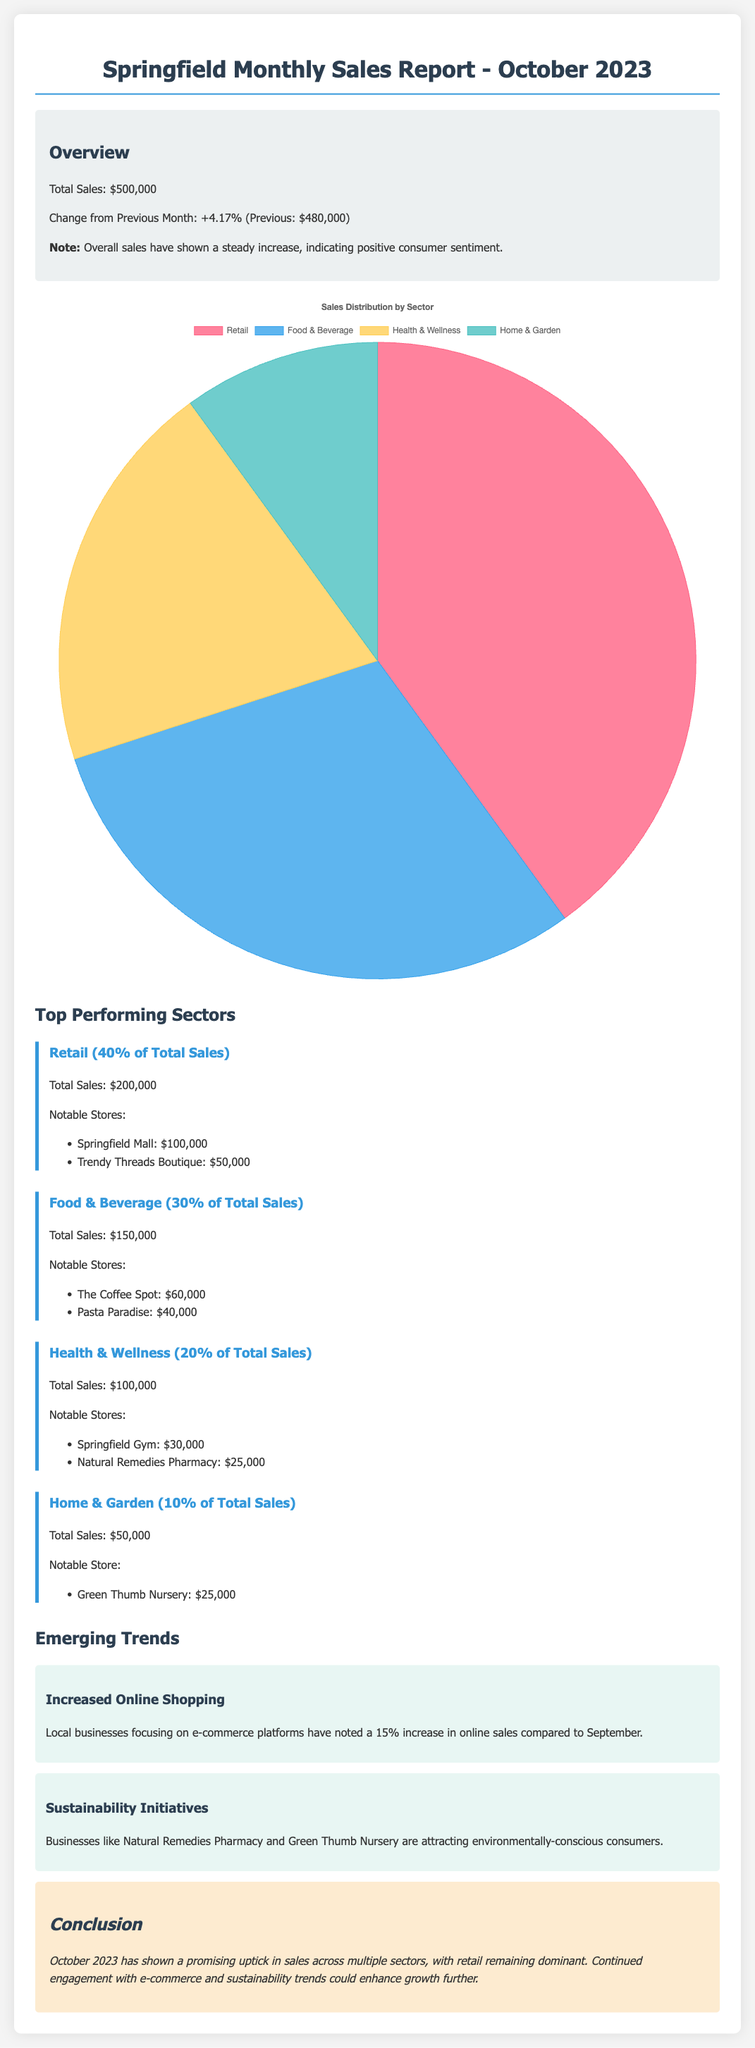What is the total sales for October 2023? The total sales for October 2023 is directly mentioned in the overview section of the document.
Answer: $500,000 What percentage of total sales does the Retail sector account for? The document specifies the percentage contribution of each sector, with Retail being clearly articulated.
Answer: 40% Which business had the highest sales in the Food & Beverage sector? The notable stores in each sector's section provide names and sales figures, pointing to the top store in this sector.
Answer: The Coffee Spot What was the change in sales from the previous month? The overview section states the change in sales, providing a direct comparison with the previous month's sales.
Answer: +4.17% What is one of the emerging trends noted in the report? The trends section lists significant trends that are influencing local businesses, one of which can be directly quoted.
Answer: Increased Online Shopping What sector shows the least sales in the report? By comparing the total sales figures presented for each sector, one can determine which has the lowest amount.
Answer: Home & Garden What is the total sales figure for the Health & Wellness sector? The sales figures for each sector are specified, enabling calculation from the stated numbers.
Answer: $100,000 What conclusion is drawn about the overall sales performance for October 2023? The conclusion summarizes the observations from the sales data and trends highlighted in the report.
Answer: Promising uptick in sales What notable store contributed $50,000 in the Retail sector? The retail sector includes a list of notable stores and their corresponding sales, making this information accessible.
Answer: Trendy Threads Boutique 